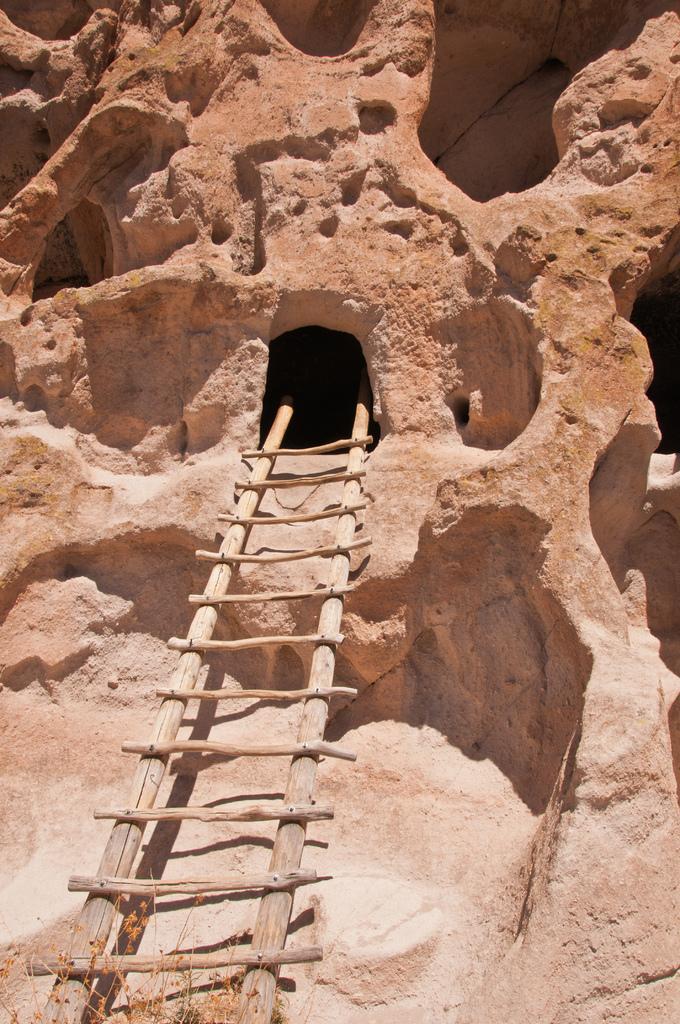Can you describe this image briefly? In this image we can see ladder to the cave. 